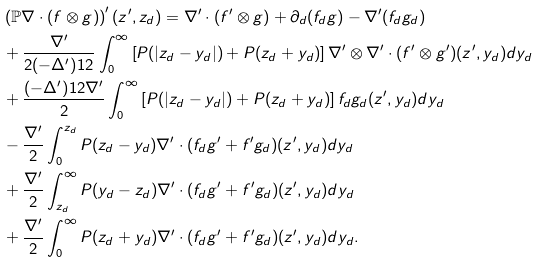Convert formula to latex. <formula><loc_0><loc_0><loc_500><loc_500>& \left ( \mathbb { P } \nabla \cdot ( f \otimes g ) \right ) ^ { \prime } ( z ^ { \prime } , z _ { d } ) = \nabla ^ { \prime } \cdot ( f ^ { \prime } \otimes g ) + \partial _ { d } ( f _ { d } g ) - \nabla ^ { \prime } ( f _ { d } g _ { d } ) \\ & + \frac { \nabla ^ { \prime } } { 2 ( - \Delta ^ { \prime } ) ^ { } { 1 } 2 } \int _ { 0 } ^ { \infty } \left [ P ( | z _ { d } - y _ { d } | ) + P ( z _ { d } + y _ { d } ) \right ] \nabla ^ { \prime } \otimes \nabla ^ { \prime } \cdot ( f ^ { \prime } \otimes g ^ { \prime } ) ( z ^ { \prime } , y _ { d } ) d y _ { d } \\ & + \frac { ( - \Delta ^ { \prime } ) ^ { } { 1 } 2 \nabla ^ { \prime } } { 2 } \int _ { 0 } ^ { \infty } \left [ P ( | z _ { d } - y _ { d } | ) + P ( z _ { d } + y _ { d } ) \right ] f _ { d } g _ { d } ( z ^ { \prime } , y _ { d } ) d y _ { d } \\ & - \frac { \nabla ^ { \prime } } 2 \int _ { 0 } ^ { z _ { d } } P ( z _ { d } - y _ { d } ) \nabla ^ { \prime } \cdot ( f _ { d } g ^ { \prime } + f ^ { \prime } g _ { d } ) ( z ^ { \prime } , y _ { d } ) d y _ { d } \\ & + \frac { \nabla ^ { \prime } } 2 \int _ { z _ { d } } ^ { \infty } P ( y _ { d } - z _ { d } ) \nabla ^ { \prime } \cdot ( f _ { d } g ^ { \prime } + f ^ { \prime } g _ { d } ) ( z ^ { \prime } , y _ { d } ) d y _ { d } \\ & + \frac { \nabla ^ { \prime } } 2 \int _ { 0 } ^ { \infty } P ( z _ { d } + y _ { d } ) \nabla ^ { \prime } \cdot ( f _ { d } g ^ { \prime } + f ^ { \prime } g _ { d } ) ( z ^ { \prime } , y _ { d } ) d y _ { d } .</formula> 